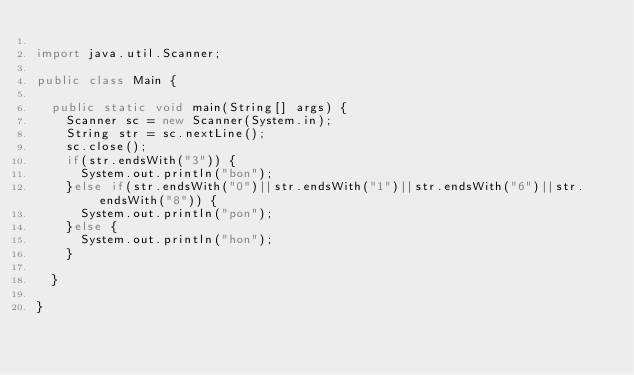Convert code to text. <code><loc_0><loc_0><loc_500><loc_500><_Java_>
import java.util.Scanner;

public class Main {

  public static void main(String[] args) {
    Scanner sc = new Scanner(System.in);
    String str = sc.nextLine();
    sc.close();
    if(str.endsWith("3")) {
      System.out.println("bon");
    }else if(str.endsWith("0")||str.endsWith("1")||str.endsWith("6")||str.endsWith("8")) {
      System.out.println("pon");
    }else {
      System.out.println("hon");
    }

  }

}
</code> 